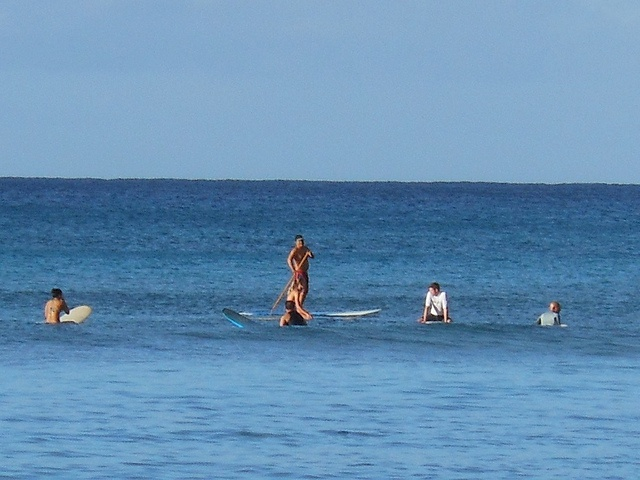Describe the objects in this image and their specific colors. I can see people in darkgray, lightgray, gray, and black tones, people in darkgray, maroon, black, brown, and gray tones, people in darkgray, black, gray, and tan tones, people in darkgray, black, gray, and maroon tones, and people in darkgray, tan, maroon, and brown tones in this image. 